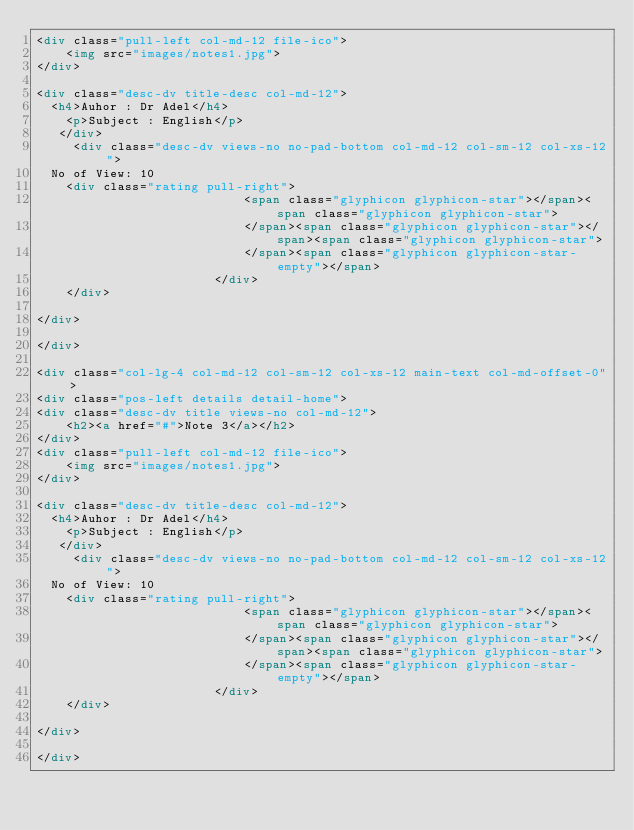<code> <loc_0><loc_0><loc_500><loc_500><_HTML_><div class="pull-left col-md-12 file-ico">
    <img src="images/notes1.jpg">
</div>

<div class="desc-dv title-desc col-md-12">
	<h4>Auhor : Dr Adel</h4>
    <p>Subject : English</p>
	 </div>
     <div class="desc-dv views-no no-pad-bottom col-md-12 col-sm-12 col-xs-12">
	No of View: 10
    <div class="rating pull-right">
                            <span class="glyphicon glyphicon-star"></span><span class="glyphicon glyphicon-star">
                            </span><span class="glyphicon glyphicon-star"></span><span class="glyphicon glyphicon-star">
                            </span><span class="glyphicon glyphicon-star-empty"></span>
                        </div>
    </div>
    
</div>

</div>

<div class="col-lg-4 col-md-12 col-sm-12 col-xs-12 main-text col-md-offset-0">
<div class="pos-left details detail-home">
<div class="desc-dv title views-no col-md-12">
    <h2><a href="#">Note 3</a></h2>
</div>
<div class="pull-left col-md-12 file-ico">
    <img src="images/notes1.jpg">
</div>

<div class="desc-dv title-desc col-md-12">
	<h4>Auhor : Dr Adel</h4>
    <p>Subject : English</p>
	 </div>
     <div class="desc-dv views-no no-pad-bottom col-md-12 col-sm-12 col-xs-12">
	No of View: 10
    <div class="rating pull-right">
                            <span class="glyphicon glyphicon-star"></span><span class="glyphicon glyphicon-star">
                            </span><span class="glyphicon glyphicon-star"></span><span class="glyphicon glyphicon-star">
                            </span><span class="glyphicon glyphicon-star-empty"></span>
                        </div>
    </div>
    
</div>

</div>
</code> 